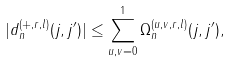Convert formula to latex. <formula><loc_0><loc_0><loc_500><loc_500>| d _ { n } ^ { ( + , r , l ) } ( j , j ^ { \prime } ) | \leq \sum _ { u , v = 0 } ^ { 1 } \Omega ^ { ( u , v , r , l ) } _ { n } ( j , j ^ { \prime } ) ,</formula> 